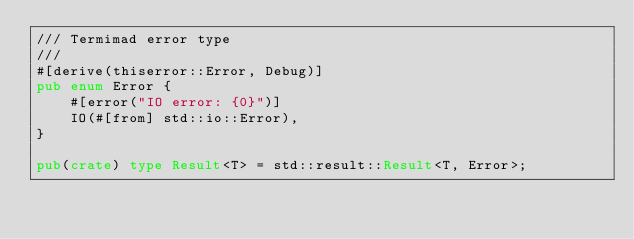<code> <loc_0><loc_0><loc_500><loc_500><_Rust_>/// Termimad error type
///
#[derive(thiserror::Error, Debug)]
pub enum Error {
    #[error("IO error: {0}")]
    IO(#[from] std::io::Error),
}

pub(crate) type Result<T> = std::result::Result<T, Error>;
</code> 